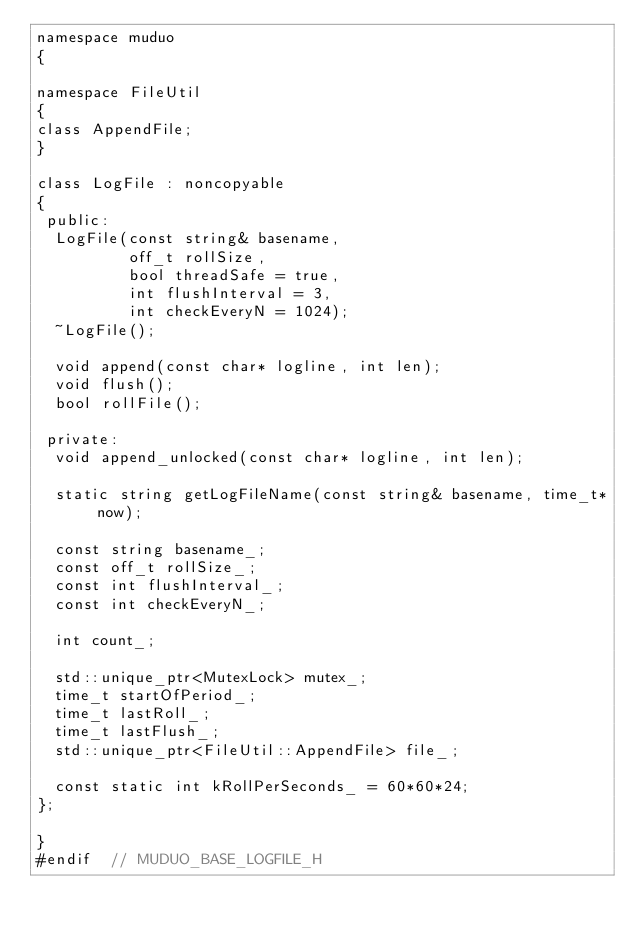<code> <loc_0><loc_0><loc_500><loc_500><_C_>namespace muduo
{

namespace FileUtil
{
class AppendFile;
}

class LogFile : noncopyable
{
 public:
  LogFile(const string& basename,
          off_t rollSize,
          bool threadSafe = true,
          int flushInterval = 3,
          int checkEveryN = 1024);
  ~LogFile();

  void append(const char* logline, int len);
  void flush();
  bool rollFile();

 private:
  void append_unlocked(const char* logline, int len);

  static string getLogFileName(const string& basename, time_t* now);

  const string basename_;
  const off_t rollSize_;
  const int flushInterval_;
  const int checkEveryN_;

  int count_;

  std::unique_ptr<MutexLock> mutex_;
  time_t startOfPeriod_;
  time_t lastRoll_;
  time_t lastFlush_;
  std::unique_ptr<FileUtil::AppendFile> file_;

  const static int kRollPerSeconds_ = 60*60*24;
};

}
#endif  // MUDUO_BASE_LOGFILE_H
</code> 